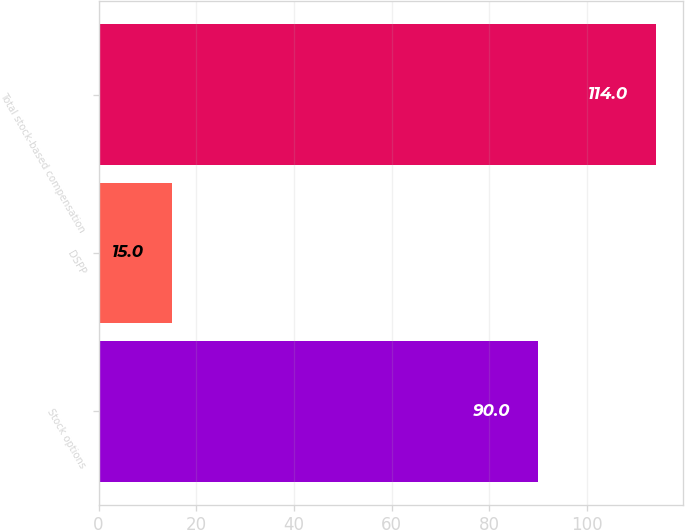Convert chart to OTSL. <chart><loc_0><loc_0><loc_500><loc_500><bar_chart><fcel>Stock options<fcel>DSPP<fcel>Total stock-based compensation<nl><fcel>90<fcel>15<fcel>114<nl></chart> 